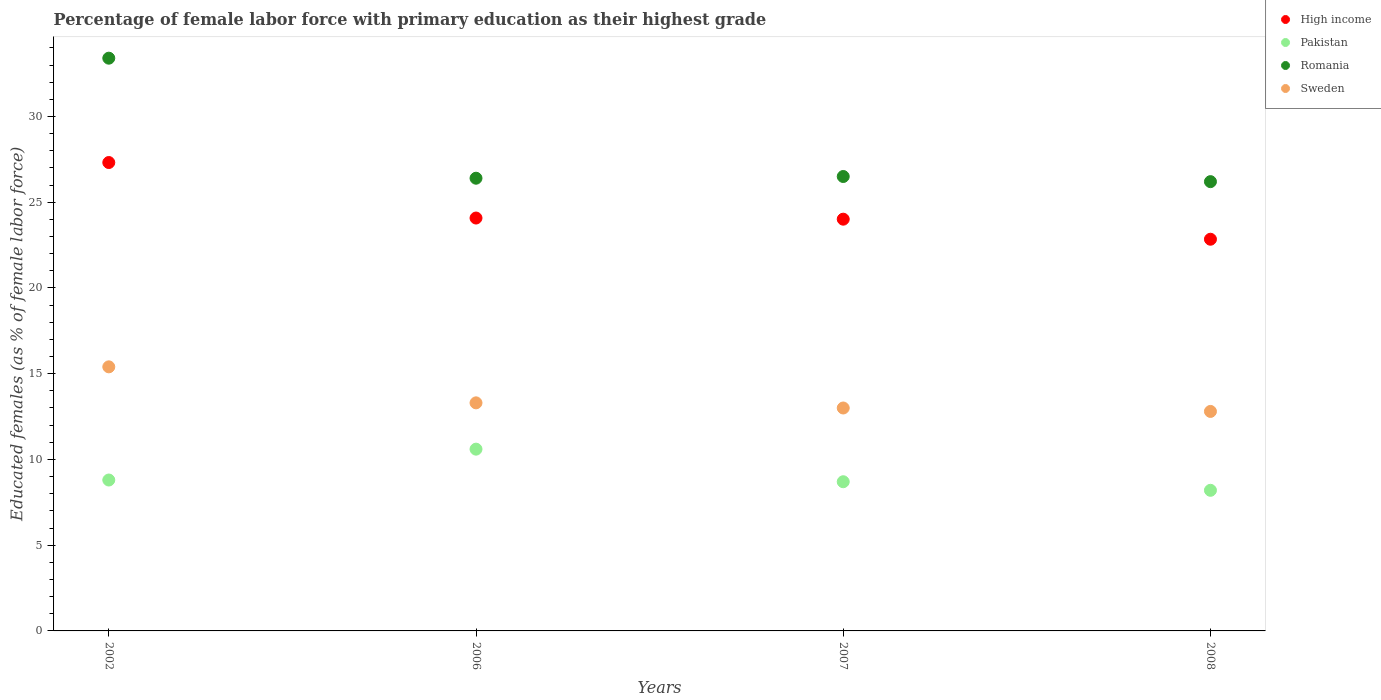What is the percentage of female labor force with primary education in Romania in 2008?
Make the answer very short. 26.2. Across all years, what is the maximum percentage of female labor force with primary education in Pakistan?
Your answer should be very brief. 10.6. Across all years, what is the minimum percentage of female labor force with primary education in High income?
Offer a terse response. 22.84. In which year was the percentage of female labor force with primary education in Romania minimum?
Provide a succinct answer. 2008. What is the total percentage of female labor force with primary education in Pakistan in the graph?
Your answer should be very brief. 36.3. What is the difference between the percentage of female labor force with primary education in High income in 2006 and that in 2007?
Keep it short and to the point. 0.07. What is the difference between the percentage of female labor force with primary education in Sweden in 2002 and the percentage of female labor force with primary education in Romania in 2008?
Ensure brevity in your answer.  -10.8. What is the average percentage of female labor force with primary education in High income per year?
Your answer should be compact. 24.56. In the year 2002, what is the difference between the percentage of female labor force with primary education in Sweden and percentage of female labor force with primary education in Romania?
Your response must be concise. -18. What is the ratio of the percentage of female labor force with primary education in Romania in 2002 to that in 2006?
Offer a terse response. 1.27. What is the difference between the highest and the second highest percentage of female labor force with primary education in High income?
Your answer should be compact. 3.24. What is the difference between the highest and the lowest percentage of female labor force with primary education in Sweden?
Ensure brevity in your answer.  2.6. Is the sum of the percentage of female labor force with primary education in High income in 2007 and 2008 greater than the maximum percentage of female labor force with primary education in Sweden across all years?
Your response must be concise. Yes. Is it the case that in every year, the sum of the percentage of female labor force with primary education in High income and percentage of female labor force with primary education in Pakistan  is greater than the sum of percentage of female labor force with primary education in Romania and percentage of female labor force with primary education in Sweden?
Give a very brief answer. No. Does the percentage of female labor force with primary education in Romania monotonically increase over the years?
Your answer should be very brief. No. Is the percentage of female labor force with primary education in Romania strictly less than the percentage of female labor force with primary education in Sweden over the years?
Offer a very short reply. No. Are the values on the major ticks of Y-axis written in scientific E-notation?
Provide a short and direct response. No. Does the graph contain any zero values?
Keep it short and to the point. No. Where does the legend appear in the graph?
Offer a very short reply. Top right. How many legend labels are there?
Offer a very short reply. 4. What is the title of the graph?
Keep it short and to the point. Percentage of female labor force with primary education as their highest grade. What is the label or title of the Y-axis?
Ensure brevity in your answer.  Educated females (as % of female labor force). What is the Educated females (as % of female labor force) in High income in 2002?
Your answer should be compact. 27.32. What is the Educated females (as % of female labor force) in Pakistan in 2002?
Make the answer very short. 8.8. What is the Educated females (as % of female labor force) in Romania in 2002?
Your response must be concise. 33.4. What is the Educated females (as % of female labor force) of Sweden in 2002?
Provide a succinct answer. 15.4. What is the Educated females (as % of female labor force) of High income in 2006?
Keep it short and to the point. 24.08. What is the Educated females (as % of female labor force) of Pakistan in 2006?
Offer a terse response. 10.6. What is the Educated females (as % of female labor force) in Romania in 2006?
Make the answer very short. 26.4. What is the Educated females (as % of female labor force) of Sweden in 2006?
Provide a short and direct response. 13.3. What is the Educated females (as % of female labor force) in High income in 2007?
Offer a very short reply. 24.01. What is the Educated females (as % of female labor force) of Pakistan in 2007?
Provide a short and direct response. 8.7. What is the Educated females (as % of female labor force) in High income in 2008?
Your answer should be very brief. 22.84. What is the Educated females (as % of female labor force) in Pakistan in 2008?
Your response must be concise. 8.2. What is the Educated females (as % of female labor force) of Romania in 2008?
Ensure brevity in your answer.  26.2. What is the Educated females (as % of female labor force) of Sweden in 2008?
Offer a very short reply. 12.8. Across all years, what is the maximum Educated females (as % of female labor force) of High income?
Provide a succinct answer. 27.32. Across all years, what is the maximum Educated females (as % of female labor force) of Pakistan?
Your answer should be very brief. 10.6. Across all years, what is the maximum Educated females (as % of female labor force) in Romania?
Keep it short and to the point. 33.4. Across all years, what is the maximum Educated females (as % of female labor force) of Sweden?
Your answer should be compact. 15.4. Across all years, what is the minimum Educated females (as % of female labor force) of High income?
Offer a terse response. 22.84. Across all years, what is the minimum Educated females (as % of female labor force) in Pakistan?
Your answer should be compact. 8.2. Across all years, what is the minimum Educated females (as % of female labor force) of Romania?
Your answer should be very brief. 26.2. Across all years, what is the minimum Educated females (as % of female labor force) in Sweden?
Your answer should be very brief. 12.8. What is the total Educated females (as % of female labor force) in High income in the graph?
Offer a very short reply. 98.25. What is the total Educated females (as % of female labor force) of Pakistan in the graph?
Provide a succinct answer. 36.3. What is the total Educated females (as % of female labor force) of Romania in the graph?
Your answer should be compact. 112.5. What is the total Educated females (as % of female labor force) in Sweden in the graph?
Keep it short and to the point. 54.5. What is the difference between the Educated females (as % of female labor force) of High income in 2002 and that in 2006?
Offer a very short reply. 3.24. What is the difference between the Educated females (as % of female labor force) of Romania in 2002 and that in 2006?
Offer a terse response. 7. What is the difference between the Educated females (as % of female labor force) of Sweden in 2002 and that in 2006?
Ensure brevity in your answer.  2.1. What is the difference between the Educated females (as % of female labor force) in High income in 2002 and that in 2007?
Ensure brevity in your answer.  3.3. What is the difference between the Educated females (as % of female labor force) in High income in 2002 and that in 2008?
Ensure brevity in your answer.  4.47. What is the difference between the Educated females (as % of female labor force) in Pakistan in 2002 and that in 2008?
Offer a very short reply. 0.6. What is the difference between the Educated females (as % of female labor force) in High income in 2006 and that in 2007?
Give a very brief answer. 0.07. What is the difference between the Educated females (as % of female labor force) in Pakistan in 2006 and that in 2007?
Your answer should be very brief. 1.9. What is the difference between the Educated females (as % of female labor force) of Romania in 2006 and that in 2007?
Make the answer very short. -0.1. What is the difference between the Educated females (as % of female labor force) in Sweden in 2006 and that in 2007?
Ensure brevity in your answer.  0.3. What is the difference between the Educated females (as % of female labor force) of High income in 2006 and that in 2008?
Provide a short and direct response. 1.24. What is the difference between the Educated females (as % of female labor force) in Romania in 2006 and that in 2008?
Ensure brevity in your answer.  0.2. What is the difference between the Educated females (as % of female labor force) of Sweden in 2006 and that in 2008?
Provide a succinct answer. 0.5. What is the difference between the Educated females (as % of female labor force) in High income in 2007 and that in 2008?
Provide a short and direct response. 1.17. What is the difference between the Educated females (as % of female labor force) in Pakistan in 2007 and that in 2008?
Your answer should be compact. 0.5. What is the difference between the Educated females (as % of female labor force) of Romania in 2007 and that in 2008?
Give a very brief answer. 0.3. What is the difference between the Educated females (as % of female labor force) in High income in 2002 and the Educated females (as % of female labor force) in Pakistan in 2006?
Your answer should be very brief. 16.71. What is the difference between the Educated females (as % of female labor force) in High income in 2002 and the Educated females (as % of female labor force) in Romania in 2006?
Your answer should be very brief. 0.92. What is the difference between the Educated females (as % of female labor force) of High income in 2002 and the Educated females (as % of female labor force) of Sweden in 2006?
Provide a succinct answer. 14.02. What is the difference between the Educated females (as % of female labor force) of Pakistan in 2002 and the Educated females (as % of female labor force) of Romania in 2006?
Make the answer very short. -17.6. What is the difference between the Educated females (as % of female labor force) in Pakistan in 2002 and the Educated females (as % of female labor force) in Sweden in 2006?
Offer a very short reply. -4.5. What is the difference between the Educated females (as % of female labor force) of Romania in 2002 and the Educated females (as % of female labor force) of Sweden in 2006?
Your answer should be very brief. 20.1. What is the difference between the Educated females (as % of female labor force) in High income in 2002 and the Educated females (as % of female labor force) in Pakistan in 2007?
Provide a succinct answer. 18.61. What is the difference between the Educated females (as % of female labor force) in High income in 2002 and the Educated females (as % of female labor force) in Romania in 2007?
Provide a succinct answer. 0.81. What is the difference between the Educated females (as % of female labor force) of High income in 2002 and the Educated females (as % of female labor force) of Sweden in 2007?
Provide a short and direct response. 14.31. What is the difference between the Educated females (as % of female labor force) of Pakistan in 2002 and the Educated females (as % of female labor force) of Romania in 2007?
Your answer should be compact. -17.7. What is the difference between the Educated females (as % of female labor force) in Romania in 2002 and the Educated females (as % of female labor force) in Sweden in 2007?
Provide a short and direct response. 20.4. What is the difference between the Educated females (as % of female labor force) of High income in 2002 and the Educated females (as % of female labor force) of Pakistan in 2008?
Provide a short and direct response. 19.11. What is the difference between the Educated females (as % of female labor force) in High income in 2002 and the Educated females (as % of female labor force) in Romania in 2008?
Offer a terse response. 1.11. What is the difference between the Educated females (as % of female labor force) of High income in 2002 and the Educated females (as % of female labor force) of Sweden in 2008?
Ensure brevity in your answer.  14.52. What is the difference between the Educated females (as % of female labor force) in Pakistan in 2002 and the Educated females (as % of female labor force) in Romania in 2008?
Your answer should be very brief. -17.4. What is the difference between the Educated females (as % of female labor force) in Pakistan in 2002 and the Educated females (as % of female labor force) in Sweden in 2008?
Your answer should be compact. -4. What is the difference between the Educated females (as % of female labor force) of Romania in 2002 and the Educated females (as % of female labor force) of Sweden in 2008?
Give a very brief answer. 20.6. What is the difference between the Educated females (as % of female labor force) in High income in 2006 and the Educated females (as % of female labor force) in Pakistan in 2007?
Keep it short and to the point. 15.38. What is the difference between the Educated females (as % of female labor force) of High income in 2006 and the Educated females (as % of female labor force) of Romania in 2007?
Give a very brief answer. -2.42. What is the difference between the Educated females (as % of female labor force) in High income in 2006 and the Educated females (as % of female labor force) in Sweden in 2007?
Your answer should be very brief. 11.08. What is the difference between the Educated females (as % of female labor force) of Pakistan in 2006 and the Educated females (as % of female labor force) of Romania in 2007?
Give a very brief answer. -15.9. What is the difference between the Educated females (as % of female labor force) of Pakistan in 2006 and the Educated females (as % of female labor force) of Sweden in 2007?
Your answer should be compact. -2.4. What is the difference between the Educated females (as % of female labor force) in Romania in 2006 and the Educated females (as % of female labor force) in Sweden in 2007?
Offer a terse response. 13.4. What is the difference between the Educated females (as % of female labor force) of High income in 2006 and the Educated females (as % of female labor force) of Pakistan in 2008?
Give a very brief answer. 15.88. What is the difference between the Educated females (as % of female labor force) of High income in 2006 and the Educated females (as % of female labor force) of Romania in 2008?
Give a very brief answer. -2.12. What is the difference between the Educated females (as % of female labor force) of High income in 2006 and the Educated females (as % of female labor force) of Sweden in 2008?
Ensure brevity in your answer.  11.28. What is the difference between the Educated females (as % of female labor force) in Pakistan in 2006 and the Educated females (as % of female labor force) in Romania in 2008?
Give a very brief answer. -15.6. What is the difference between the Educated females (as % of female labor force) of Pakistan in 2006 and the Educated females (as % of female labor force) of Sweden in 2008?
Your answer should be very brief. -2.2. What is the difference between the Educated females (as % of female labor force) in High income in 2007 and the Educated females (as % of female labor force) in Pakistan in 2008?
Give a very brief answer. 15.81. What is the difference between the Educated females (as % of female labor force) in High income in 2007 and the Educated females (as % of female labor force) in Romania in 2008?
Your answer should be compact. -2.19. What is the difference between the Educated females (as % of female labor force) in High income in 2007 and the Educated females (as % of female labor force) in Sweden in 2008?
Your answer should be compact. 11.21. What is the difference between the Educated females (as % of female labor force) of Pakistan in 2007 and the Educated females (as % of female labor force) of Romania in 2008?
Your response must be concise. -17.5. What is the difference between the Educated females (as % of female labor force) of Pakistan in 2007 and the Educated females (as % of female labor force) of Sweden in 2008?
Provide a short and direct response. -4.1. What is the difference between the Educated females (as % of female labor force) of Romania in 2007 and the Educated females (as % of female labor force) of Sweden in 2008?
Keep it short and to the point. 13.7. What is the average Educated females (as % of female labor force) of High income per year?
Your answer should be compact. 24.56. What is the average Educated females (as % of female labor force) of Pakistan per year?
Offer a terse response. 9.07. What is the average Educated females (as % of female labor force) in Romania per year?
Offer a terse response. 28.12. What is the average Educated females (as % of female labor force) of Sweden per year?
Provide a short and direct response. 13.62. In the year 2002, what is the difference between the Educated females (as % of female labor force) of High income and Educated females (as % of female labor force) of Pakistan?
Keep it short and to the point. 18.52. In the year 2002, what is the difference between the Educated females (as % of female labor force) of High income and Educated females (as % of female labor force) of Romania?
Offer a terse response. -6.08. In the year 2002, what is the difference between the Educated females (as % of female labor force) in High income and Educated females (as % of female labor force) in Sweden?
Keep it short and to the point. 11.91. In the year 2002, what is the difference between the Educated females (as % of female labor force) of Pakistan and Educated females (as % of female labor force) of Romania?
Give a very brief answer. -24.6. In the year 2002, what is the difference between the Educated females (as % of female labor force) of Pakistan and Educated females (as % of female labor force) of Sweden?
Your response must be concise. -6.6. In the year 2002, what is the difference between the Educated females (as % of female labor force) of Romania and Educated females (as % of female labor force) of Sweden?
Keep it short and to the point. 18. In the year 2006, what is the difference between the Educated females (as % of female labor force) in High income and Educated females (as % of female labor force) in Pakistan?
Provide a short and direct response. 13.48. In the year 2006, what is the difference between the Educated females (as % of female labor force) of High income and Educated females (as % of female labor force) of Romania?
Your answer should be very brief. -2.32. In the year 2006, what is the difference between the Educated females (as % of female labor force) in High income and Educated females (as % of female labor force) in Sweden?
Offer a very short reply. 10.78. In the year 2006, what is the difference between the Educated females (as % of female labor force) in Pakistan and Educated females (as % of female labor force) in Romania?
Your answer should be very brief. -15.8. In the year 2006, what is the difference between the Educated females (as % of female labor force) of Pakistan and Educated females (as % of female labor force) of Sweden?
Keep it short and to the point. -2.7. In the year 2006, what is the difference between the Educated females (as % of female labor force) in Romania and Educated females (as % of female labor force) in Sweden?
Provide a short and direct response. 13.1. In the year 2007, what is the difference between the Educated females (as % of female labor force) of High income and Educated females (as % of female labor force) of Pakistan?
Your response must be concise. 15.31. In the year 2007, what is the difference between the Educated females (as % of female labor force) of High income and Educated females (as % of female labor force) of Romania?
Ensure brevity in your answer.  -2.49. In the year 2007, what is the difference between the Educated females (as % of female labor force) in High income and Educated females (as % of female labor force) in Sweden?
Offer a very short reply. 11.01. In the year 2007, what is the difference between the Educated females (as % of female labor force) in Pakistan and Educated females (as % of female labor force) in Romania?
Give a very brief answer. -17.8. In the year 2008, what is the difference between the Educated females (as % of female labor force) in High income and Educated females (as % of female labor force) in Pakistan?
Provide a succinct answer. 14.64. In the year 2008, what is the difference between the Educated females (as % of female labor force) of High income and Educated females (as % of female labor force) of Romania?
Your answer should be compact. -3.36. In the year 2008, what is the difference between the Educated females (as % of female labor force) in High income and Educated females (as % of female labor force) in Sweden?
Keep it short and to the point. 10.04. In the year 2008, what is the difference between the Educated females (as % of female labor force) in Pakistan and Educated females (as % of female labor force) in Romania?
Give a very brief answer. -18. What is the ratio of the Educated females (as % of female labor force) of High income in 2002 to that in 2006?
Offer a very short reply. 1.13. What is the ratio of the Educated females (as % of female labor force) in Pakistan in 2002 to that in 2006?
Provide a short and direct response. 0.83. What is the ratio of the Educated females (as % of female labor force) in Romania in 2002 to that in 2006?
Ensure brevity in your answer.  1.27. What is the ratio of the Educated females (as % of female labor force) in Sweden in 2002 to that in 2006?
Offer a very short reply. 1.16. What is the ratio of the Educated females (as % of female labor force) in High income in 2002 to that in 2007?
Keep it short and to the point. 1.14. What is the ratio of the Educated females (as % of female labor force) in Pakistan in 2002 to that in 2007?
Ensure brevity in your answer.  1.01. What is the ratio of the Educated females (as % of female labor force) of Romania in 2002 to that in 2007?
Make the answer very short. 1.26. What is the ratio of the Educated females (as % of female labor force) in Sweden in 2002 to that in 2007?
Your answer should be compact. 1.18. What is the ratio of the Educated females (as % of female labor force) of High income in 2002 to that in 2008?
Keep it short and to the point. 1.2. What is the ratio of the Educated females (as % of female labor force) in Pakistan in 2002 to that in 2008?
Keep it short and to the point. 1.07. What is the ratio of the Educated females (as % of female labor force) of Romania in 2002 to that in 2008?
Provide a succinct answer. 1.27. What is the ratio of the Educated females (as % of female labor force) in Sweden in 2002 to that in 2008?
Provide a succinct answer. 1.2. What is the ratio of the Educated females (as % of female labor force) in Pakistan in 2006 to that in 2007?
Provide a succinct answer. 1.22. What is the ratio of the Educated females (as % of female labor force) of Sweden in 2006 to that in 2007?
Ensure brevity in your answer.  1.02. What is the ratio of the Educated females (as % of female labor force) of High income in 2006 to that in 2008?
Make the answer very short. 1.05. What is the ratio of the Educated females (as % of female labor force) in Pakistan in 2006 to that in 2008?
Provide a succinct answer. 1.29. What is the ratio of the Educated females (as % of female labor force) in Romania in 2006 to that in 2008?
Keep it short and to the point. 1.01. What is the ratio of the Educated females (as % of female labor force) in Sweden in 2006 to that in 2008?
Provide a succinct answer. 1.04. What is the ratio of the Educated females (as % of female labor force) in High income in 2007 to that in 2008?
Your answer should be compact. 1.05. What is the ratio of the Educated females (as % of female labor force) in Pakistan in 2007 to that in 2008?
Provide a short and direct response. 1.06. What is the ratio of the Educated females (as % of female labor force) in Romania in 2007 to that in 2008?
Offer a very short reply. 1.01. What is the ratio of the Educated females (as % of female labor force) in Sweden in 2007 to that in 2008?
Make the answer very short. 1.02. What is the difference between the highest and the second highest Educated females (as % of female labor force) in High income?
Provide a succinct answer. 3.24. What is the difference between the highest and the second highest Educated females (as % of female labor force) in Pakistan?
Provide a succinct answer. 1.8. What is the difference between the highest and the second highest Educated females (as % of female labor force) of Sweden?
Ensure brevity in your answer.  2.1. What is the difference between the highest and the lowest Educated females (as % of female labor force) of High income?
Your answer should be very brief. 4.47. 